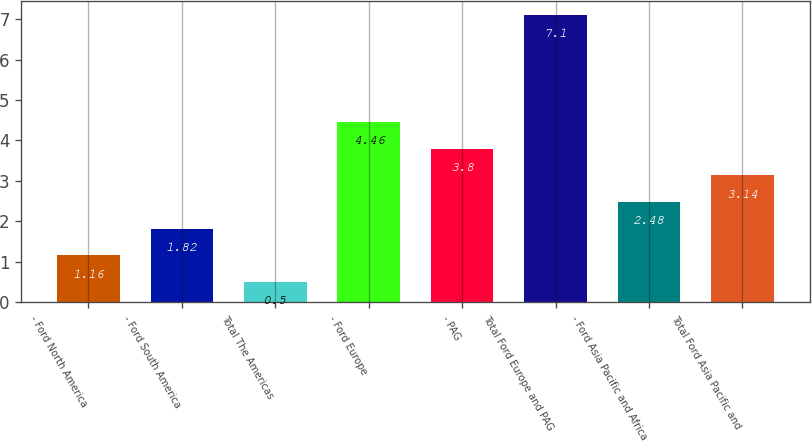Convert chart to OTSL. <chart><loc_0><loc_0><loc_500><loc_500><bar_chart><fcel>- Ford North America<fcel>- Ford South America<fcel>Total The Americas<fcel>- Ford Europe<fcel>- PAG<fcel>Total Ford Europe and PAG<fcel>- Ford Asia Pacific and Africa<fcel>Total Ford Asia Pacific and<nl><fcel>1.16<fcel>1.82<fcel>0.5<fcel>4.46<fcel>3.8<fcel>7.1<fcel>2.48<fcel>3.14<nl></chart> 